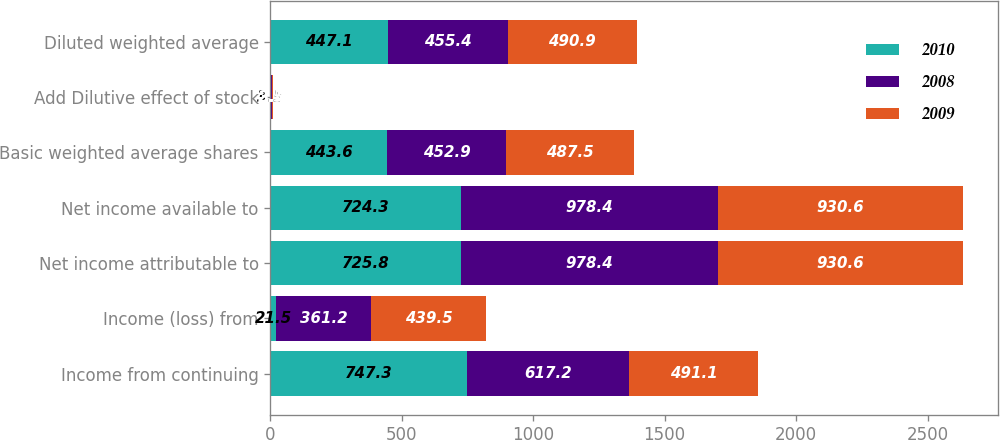Convert chart to OTSL. <chart><loc_0><loc_0><loc_500><loc_500><stacked_bar_chart><ecel><fcel>Income from continuing<fcel>Income (loss) from<fcel>Net income attributable to<fcel>Net income available to<fcel>Basic weighted average shares<fcel>Add Dilutive effect of stock<fcel>Diluted weighted average<nl><fcel>2010<fcel>747.3<fcel>21.5<fcel>725.8<fcel>724.3<fcel>443.6<fcel>3.5<fcel>447.1<nl><fcel>2008<fcel>617.2<fcel>361.2<fcel>978.4<fcel>978.4<fcel>452.9<fcel>2.5<fcel>455.4<nl><fcel>2009<fcel>491.1<fcel>439.5<fcel>930.6<fcel>930.6<fcel>487.5<fcel>3.4<fcel>490.9<nl></chart> 